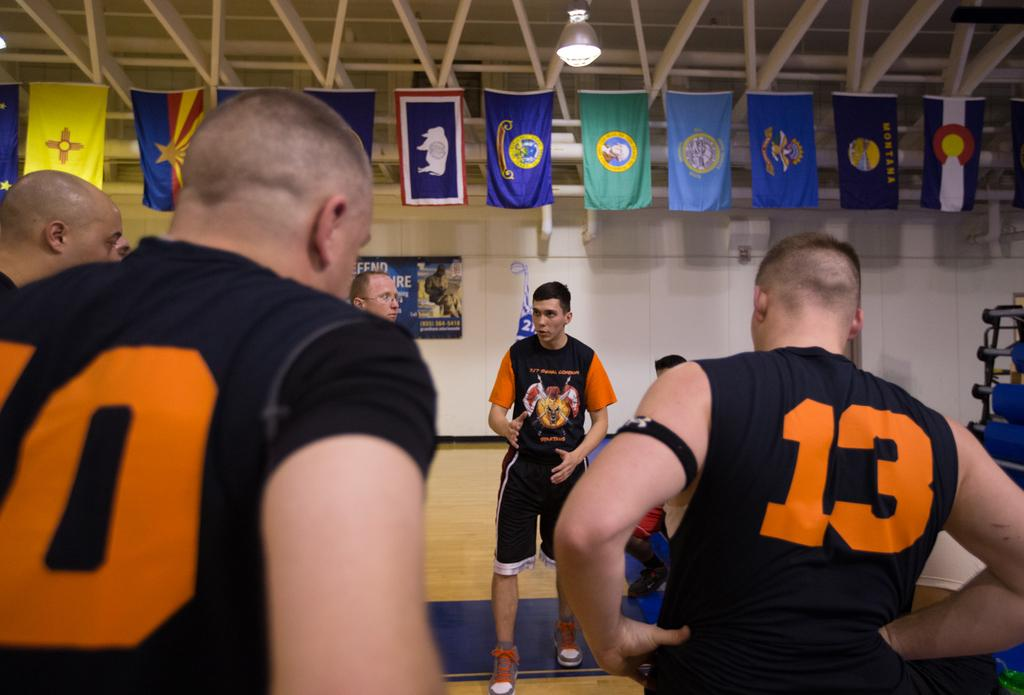Provide a one-sentence caption for the provided image. Two men wearing numbers 10 and 13 listening to another man speak. 